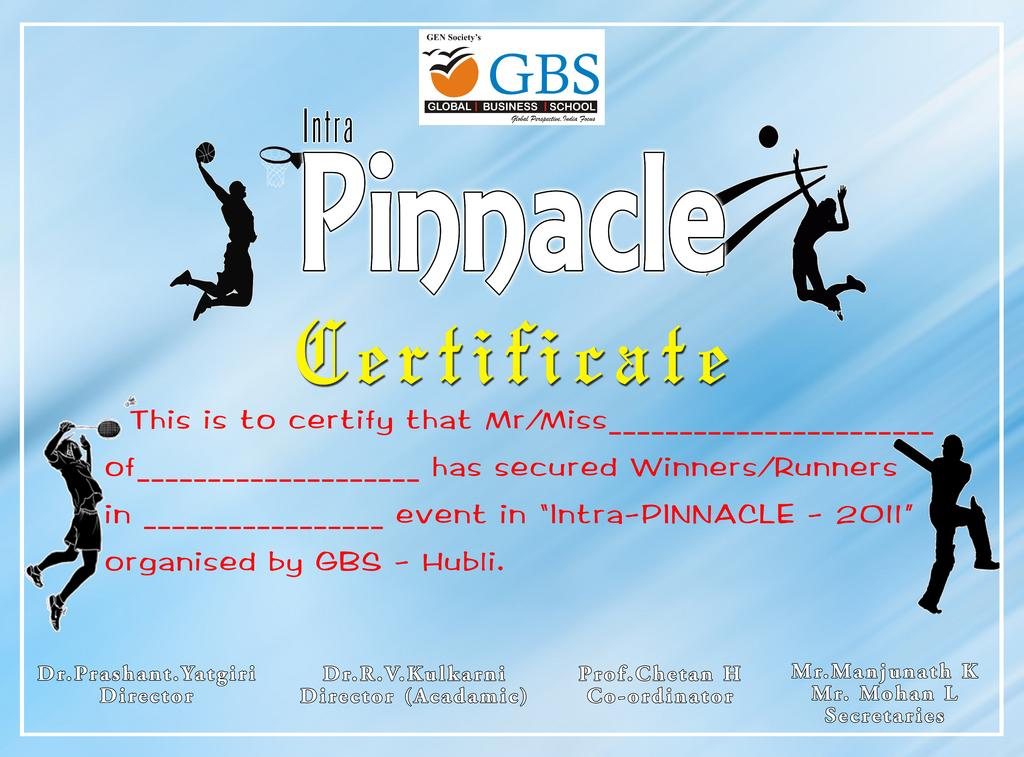Provide a one-sentence caption for the provided image. intra pinnacle certificate ad for completing the work. 